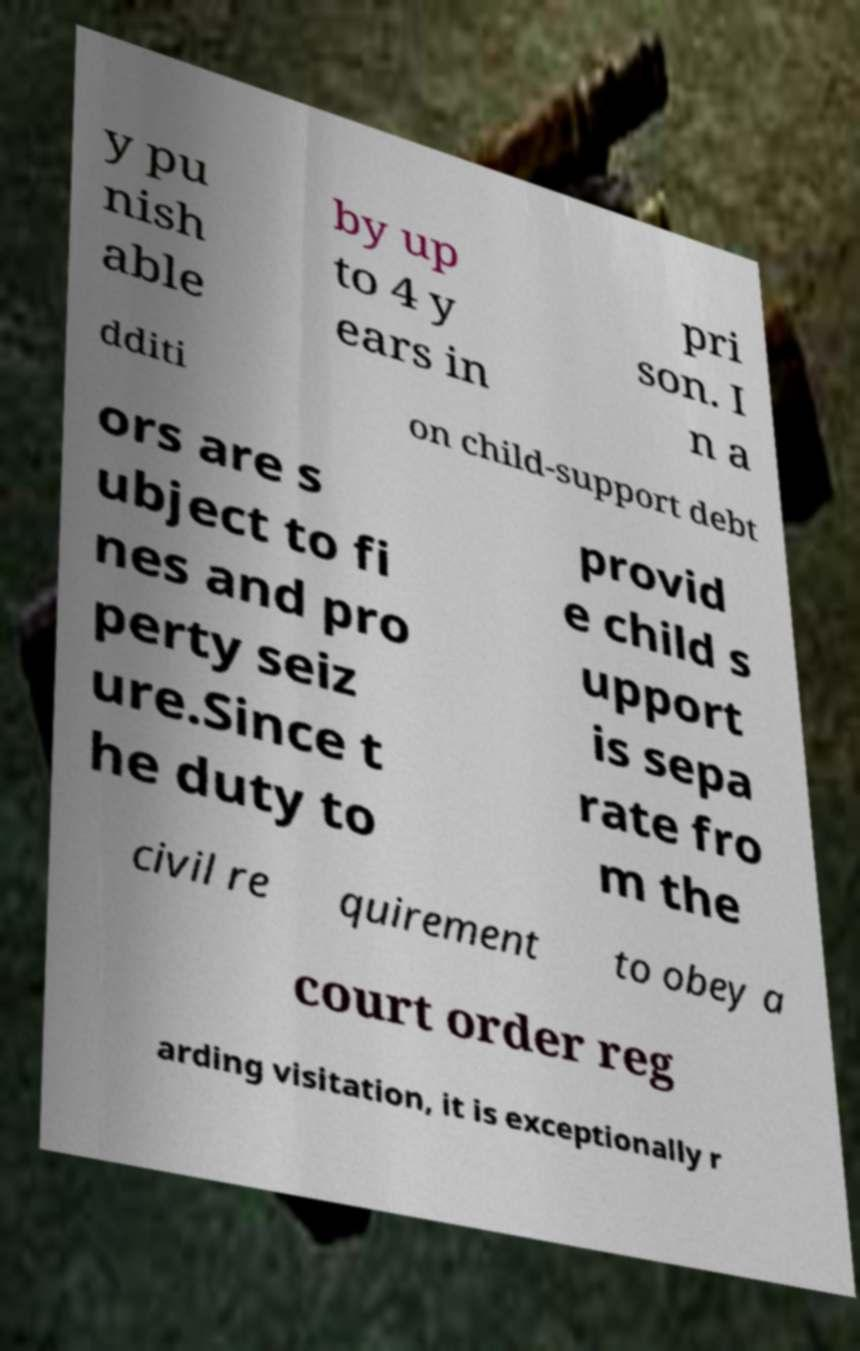Can you accurately transcribe the text from the provided image for me? y pu nish able by up to 4 y ears in pri son. I n a dditi on child-support debt ors are s ubject to fi nes and pro perty seiz ure.Since t he duty to provid e child s upport is sepa rate fro m the civil re quirement to obey a court order reg arding visitation, it is exceptionally r 